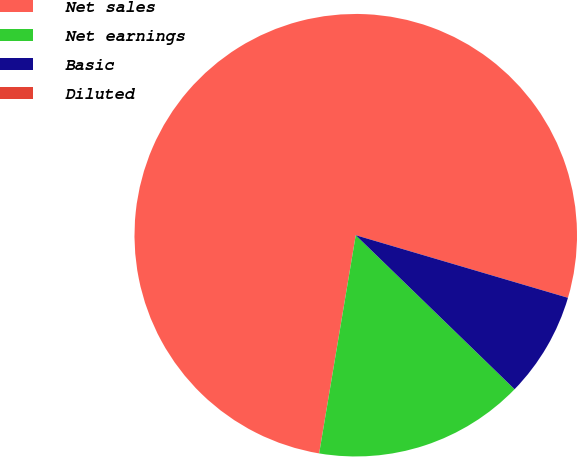Convert chart. <chart><loc_0><loc_0><loc_500><loc_500><pie_chart><fcel>Net sales<fcel>Net earnings<fcel>Basic<fcel>Diluted<nl><fcel>76.92%<fcel>15.39%<fcel>7.69%<fcel>0.0%<nl></chart> 